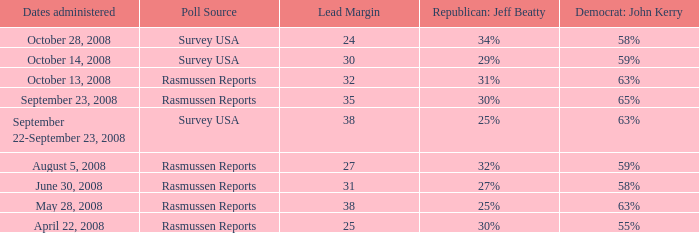When does the 34% mark occur for republican jeaff beatty? October 28, 2008. 